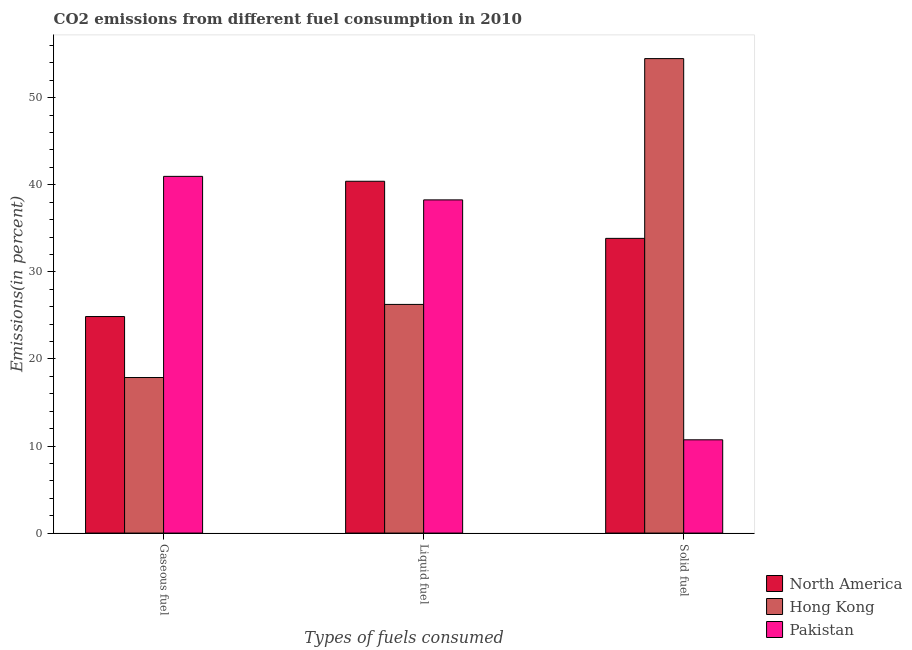How many different coloured bars are there?
Provide a short and direct response. 3. How many bars are there on the 2nd tick from the left?
Provide a short and direct response. 3. How many bars are there on the 2nd tick from the right?
Ensure brevity in your answer.  3. What is the label of the 1st group of bars from the left?
Give a very brief answer. Gaseous fuel. What is the percentage of solid fuel emission in North America?
Offer a very short reply. 33.85. Across all countries, what is the maximum percentage of gaseous fuel emission?
Ensure brevity in your answer.  40.97. Across all countries, what is the minimum percentage of solid fuel emission?
Your response must be concise. 10.71. In which country was the percentage of solid fuel emission maximum?
Provide a succinct answer. Hong Kong. What is the total percentage of solid fuel emission in the graph?
Make the answer very short. 99.06. What is the difference between the percentage of gaseous fuel emission in Hong Kong and that in Pakistan?
Provide a short and direct response. -23.1. What is the difference between the percentage of liquid fuel emission in North America and the percentage of gaseous fuel emission in Pakistan?
Keep it short and to the point. -0.56. What is the average percentage of gaseous fuel emission per country?
Your answer should be very brief. 27.9. What is the difference between the percentage of solid fuel emission and percentage of liquid fuel emission in Hong Kong?
Offer a very short reply. 28.23. What is the ratio of the percentage of liquid fuel emission in Hong Kong to that in Pakistan?
Your answer should be very brief. 0.69. What is the difference between the highest and the second highest percentage of liquid fuel emission?
Make the answer very short. 2.14. What is the difference between the highest and the lowest percentage of liquid fuel emission?
Make the answer very short. 14.14. In how many countries, is the percentage of solid fuel emission greater than the average percentage of solid fuel emission taken over all countries?
Provide a short and direct response. 2. Is the sum of the percentage of solid fuel emission in Pakistan and Hong Kong greater than the maximum percentage of gaseous fuel emission across all countries?
Offer a very short reply. Yes. What does the 3rd bar from the left in Gaseous fuel represents?
Ensure brevity in your answer.  Pakistan. What does the 3rd bar from the right in Gaseous fuel represents?
Keep it short and to the point. North America. Is it the case that in every country, the sum of the percentage of gaseous fuel emission and percentage of liquid fuel emission is greater than the percentage of solid fuel emission?
Your response must be concise. No. How many bars are there?
Offer a terse response. 9. Are the values on the major ticks of Y-axis written in scientific E-notation?
Provide a succinct answer. No. Where does the legend appear in the graph?
Make the answer very short. Bottom right. What is the title of the graph?
Keep it short and to the point. CO2 emissions from different fuel consumption in 2010. Does "Thailand" appear as one of the legend labels in the graph?
Your answer should be compact. No. What is the label or title of the X-axis?
Ensure brevity in your answer.  Types of fuels consumed. What is the label or title of the Y-axis?
Your answer should be very brief. Emissions(in percent). What is the Emissions(in percent) of North America in Gaseous fuel?
Make the answer very short. 24.87. What is the Emissions(in percent) in Hong Kong in Gaseous fuel?
Your response must be concise. 17.87. What is the Emissions(in percent) in Pakistan in Gaseous fuel?
Give a very brief answer. 40.97. What is the Emissions(in percent) in North America in Liquid fuel?
Provide a short and direct response. 40.41. What is the Emissions(in percent) of Hong Kong in Liquid fuel?
Your answer should be compact. 26.26. What is the Emissions(in percent) in Pakistan in Liquid fuel?
Offer a terse response. 38.27. What is the Emissions(in percent) in North America in Solid fuel?
Keep it short and to the point. 33.85. What is the Emissions(in percent) in Hong Kong in Solid fuel?
Your response must be concise. 54.5. What is the Emissions(in percent) of Pakistan in Solid fuel?
Offer a very short reply. 10.71. Across all Types of fuels consumed, what is the maximum Emissions(in percent) in North America?
Offer a very short reply. 40.41. Across all Types of fuels consumed, what is the maximum Emissions(in percent) in Hong Kong?
Provide a short and direct response. 54.5. Across all Types of fuels consumed, what is the maximum Emissions(in percent) in Pakistan?
Provide a short and direct response. 40.97. Across all Types of fuels consumed, what is the minimum Emissions(in percent) of North America?
Your answer should be compact. 24.87. Across all Types of fuels consumed, what is the minimum Emissions(in percent) in Hong Kong?
Offer a very short reply. 17.87. Across all Types of fuels consumed, what is the minimum Emissions(in percent) of Pakistan?
Ensure brevity in your answer.  10.71. What is the total Emissions(in percent) of North America in the graph?
Give a very brief answer. 99.13. What is the total Emissions(in percent) in Hong Kong in the graph?
Keep it short and to the point. 98.63. What is the total Emissions(in percent) of Pakistan in the graph?
Offer a terse response. 89.95. What is the difference between the Emissions(in percent) of North America in Gaseous fuel and that in Liquid fuel?
Provide a short and direct response. -15.54. What is the difference between the Emissions(in percent) of Hong Kong in Gaseous fuel and that in Liquid fuel?
Offer a terse response. -8.4. What is the difference between the Emissions(in percent) in Pakistan in Gaseous fuel and that in Liquid fuel?
Your response must be concise. 2.7. What is the difference between the Emissions(in percent) in North America in Gaseous fuel and that in Solid fuel?
Provide a succinct answer. -8.98. What is the difference between the Emissions(in percent) in Hong Kong in Gaseous fuel and that in Solid fuel?
Keep it short and to the point. -36.63. What is the difference between the Emissions(in percent) of Pakistan in Gaseous fuel and that in Solid fuel?
Make the answer very short. 30.26. What is the difference between the Emissions(in percent) in North America in Liquid fuel and that in Solid fuel?
Your answer should be very brief. 6.56. What is the difference between the Emissions(in percent) of Hong Kong in Liquid fuel and that in Solid fuel?
Make the answer very short. -28.23. What is the difference between the Emissions(in percent) in Pakistan in Liquid fuel and that in Solid fuel?
Give a very brief answer. 27.56. What is the difference between the Emissions(in percent) in North America in Gaseous fuel and the Emissions(in percent) in Hong Kong in Liquid fuel?
Provide a short and direct response. -1.39. What is the difference between the Emissions(in percent) in North America in Gaseous fuel and the Emissions(in percent) in Pakistan in Liquid fuel?
Give a very brief answer. -13.4. What is the difference between the Emissions(in percent) in Hong Kong in Gaseous fuel and the Emissions(in percent) in Pakistan in Liquid fuel?
Your response must be concise. -20.4. What is the difference between the Emissions(in percent) in North America in Gaseous fuel and the Emissions(in percent) in Hong Kong in Solid fuel?
Offer a very short reply. -29.63. What is the difference between the Emissions(in percent) in North America in Gaseous fuel and the Emissions(in percent) in Pakistan in Solid fuel?
Your response must be concise. 14.16. What is the difference between the Emissions(in percent) of Hong Kong in Gaseous fuel and the Emissions(in percent) of Pakistan in Solid fuel?
Offer a very short reply. 7.15. What is the difference between the Emissions(in percent) in North America in Liquid fuel and the Emissions(in percent) in Hong Kong in Solid fuel?
Your response must be concise. -14.09. What is the difference between the Emissions(in percent) in North America in Liquid fuel and the Emissions(in percent) in Pakistan in Solid fuel?
Offer a very short reply. 29.69. What is the difference between the Emissions(in percent) in Hong Kong in Liquid fuel and the Emissions(in percent) in Pakistan in Solid fuel?
Offer a very short reply. 15.55. What is the average Emissions(in percent) of North America per Types of fuels consumed?
Give a very brief answer. 33.04. What is the average Emissions(in percent) of Hong Kong per Types of fuels consumed?
Your answer should be very brief. 32.88. What is the average Emissions(in percent) in Pakistan per Types of fuels consumed?
Provide a succinct answer. 29.98. What is the difference between the Emissions(in percent) in North America and Emissions(in percent) in Hong Kong in Gaseous fuel?
Provide a short and direct response. 7. What is the difference between the Emissions(in percent) in North America and Emissions(in percent) in Pakistan in Gaseous fuel?
Your answer should be very brief. -16.1. What is the difference between the Emissions(in percent) of Hong Kong and Emissions(in percent) of Pakistan in Gaseous fuel?
Keep it short and to the point. -23.1. What is the difference between the Emissions(in percent) in North America and Emissions(in percent) in Hong Kong in Liquid fuel?
Keep it short and to the point. 14.14. What is the difference between the Emissions(in percent) in North America and Emissions(in percent) in Pakistan in Liquid fuel?
Offer a terse response. 2.14. What is the difference between the Emissions(in percent) in Hong Kong and Emissions(in percent) in Pakistan in Liquid fuel?
Provide a succinct answer. -12.01. What is the difference between the Emissions(in percent) of North America and Emissions(in percent) of Hong Kong in Solid fuel?
Offer a terse response. -20.65. What is the difference between the Emissions(in percent) in North America and Emissions(in percent) in Pakistan in Solid fuel?
Your answer should be compact. 23.14. What is the difference between the Emissions(in percent) of Hong Kong and Emissions(in percent) of Pakistan in Solid fuel?
Your response must be concise. 43.78. What is the ratio of the Emissions(in percent) in North America in Gaseous fuel to that in Liquid fuel?
Your answer should be compact. 0.62. What is the ratio of the Emissions(in percent) in Hong Kong in Gaseous fuel to that in Liquid fuel?
Provide a short and direct response. 0.68. What is the ratio of the Emissions(in percent) of Pakistan in Gaseous fuel to that in Liquid fuel?
Provide a short and direct response. 1.07. What is the ratio of the Emissions(in percent) of North America in Gaseous fuel to that in Solid fuel?
Provide a succinct answer. 0.73. What is the ratio of the Emissions(in percent) in Hong Kong in Gaseous fuel to that in Solid fuel?
Your response must be concise. 0.33. What is the ratio of the Emissions(in percent) in Pakistan in Gaseous fuel to that in Solid fuel?
Provide a short and direct response. 3.82. What is the ratio of the Emissions(in percent) of North America in Liquid fuel to that in Solid fuel?
Your response must be concise. 1.19. What is the ratio of the Emissions(in percent) in Hong Kong in Liquid fuel to that in Solid fuel?
Provide a succinct answer. 0.48. What is the ratio of the Emissions(in percent) in Pakistan in Liquid fuel to that in Solid fuel?
Offer a terse response. 3.57. What is the difference between the highest and the second highest Emissions(in percent) in North America?
Give a very brief answer. 6.56. What is the difference between the highest and the second highest Emissions(in percent) of Hong Kong?
Your response must be concise. 28.23. What is the difference between the highest and the second highest Emissions(in percent) of Pakistan?
Your response must be concise. 2.7. What is the difference between the highest and the lowest Emissions(in percent) in North America?
Offer a very short reply. 15.54. What is the difference between the highest and the lowest Emissions(in percent) of Hong Kong?
Your response must be concise. 36.63. What is the difference between the highest and the lowest Emissions(in percent) of Pakistan?
Provide a succinct answer. 30.26. 